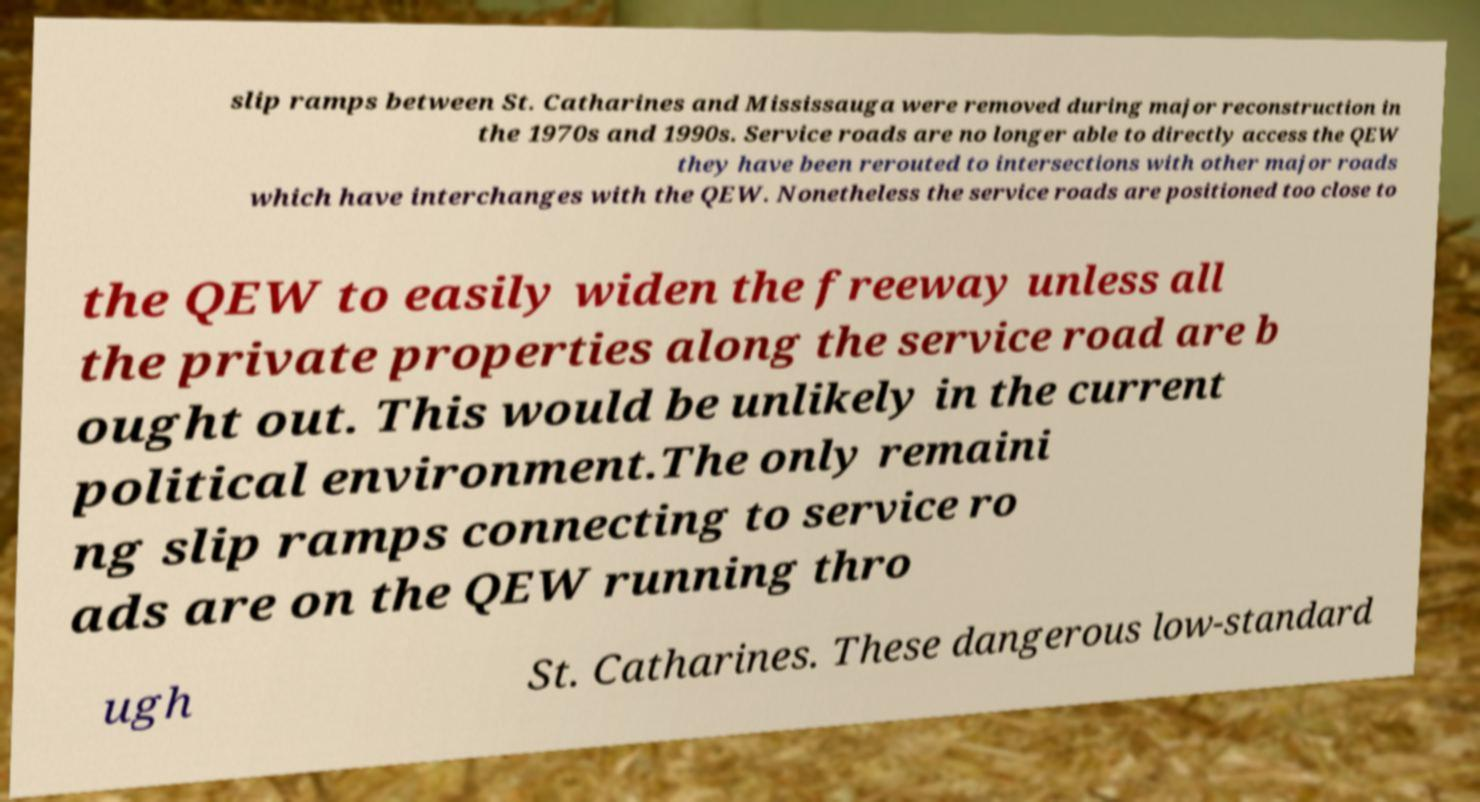I need the written content from this picture converted into text. Can you do that? slip ramps between St. Catharines and Mississauga were removed during major reconstruction in the 1970s and 1990s. Service roads are no longer able to directly access the QEW they have been rerouted to intersections with other major roads which have interchanges with the QEW. Nonetheless the service roads are positioned too close to the QEW to easily widen the freeway unless all the private properties along the service road are b ought out. This would be unlikely in the current political environment.The only remaini ng slip ramps connecting to service ro ads are on the QEW running thro ugh St. Catharines. These dangerous low-standard 